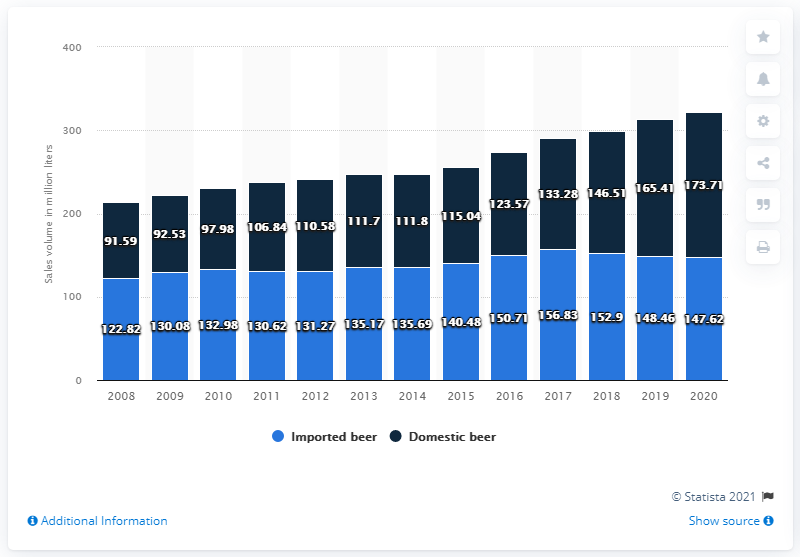List a handful of essential elements in this visual. The highest sales volume of imported beer is 156.83. The total sales volume of beers in 2009 was 222.61. The sales volume of imported beer in Ontario in 2020 was 147.62 million. 